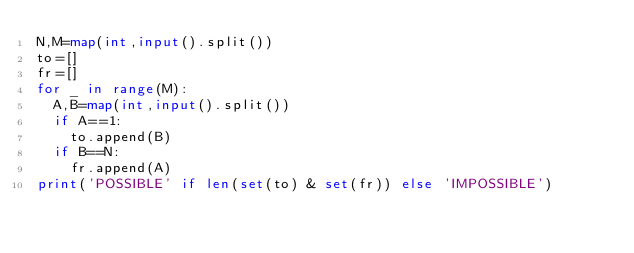Convert code to text. <code><loc_0><loc_0><loc_500><loc_500><_Python_>N,M=map(int,input().split())
to=[]
fr=[]
for _ in range(M):
  A,B=map(int,input().split())
  if A==1:
    to.append(B)
  if B==N:
    fr.append(A)
print('POSSIBLE' if len(set(to) & set(fr)) else 'IMPOSSIBLE')

</code> 